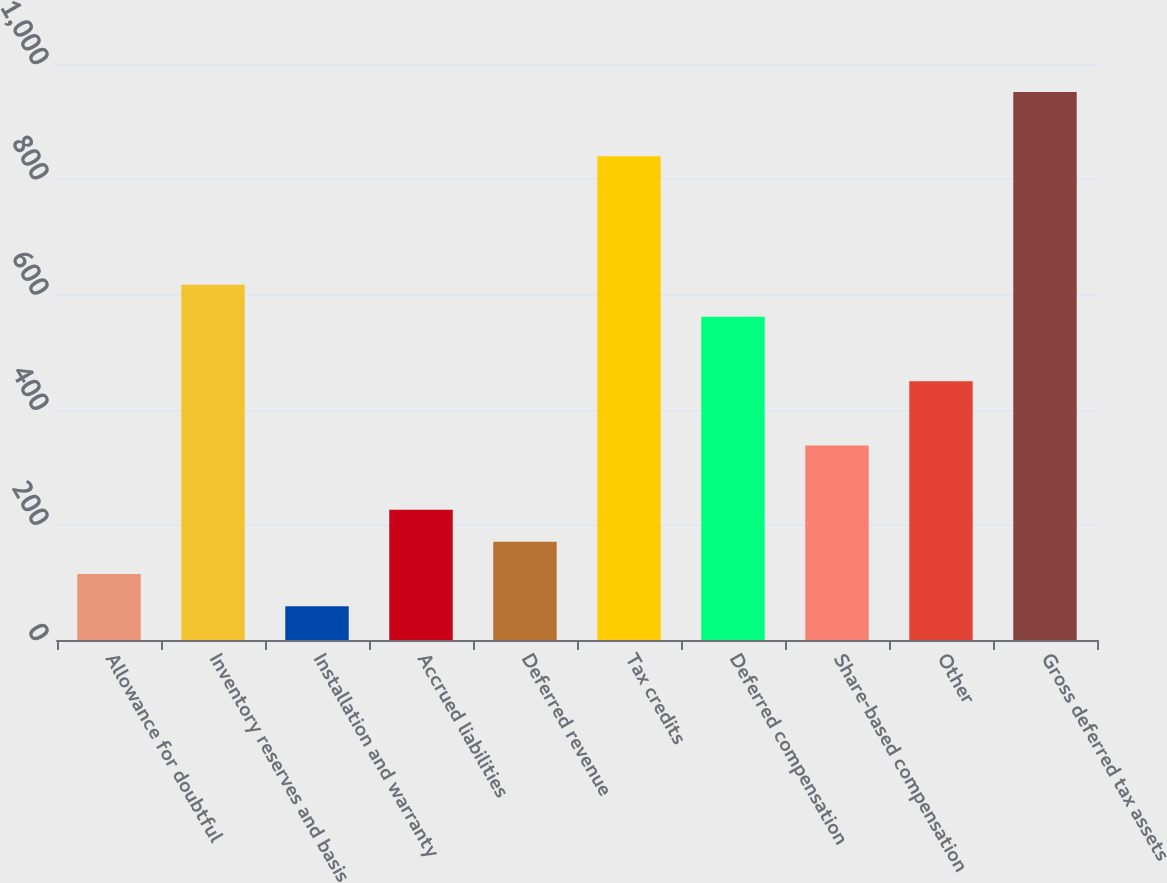<chart> <loc_0><loc_0><loc_500><loc_500><bar_chart><fcel>Allowance for doubtful<fcel>Inventory reserves and basis<fcel>Installation and warranty<fcel>Accrued liabilities<fcel>Deferred revenue<fcel>Tax credits<fcel>Deferred compensation<fcel>Share-based compensation<fcel>Other<fcel>Gross deferred tax assets<nl><fcel>114.6<fcel>616.8<fcel>58.8<fcel>226.2<fcel>170.4<fcel>840<fcel>561<fcel>337.8<fcel>449.4<fcel>951.6<nl></chart> 